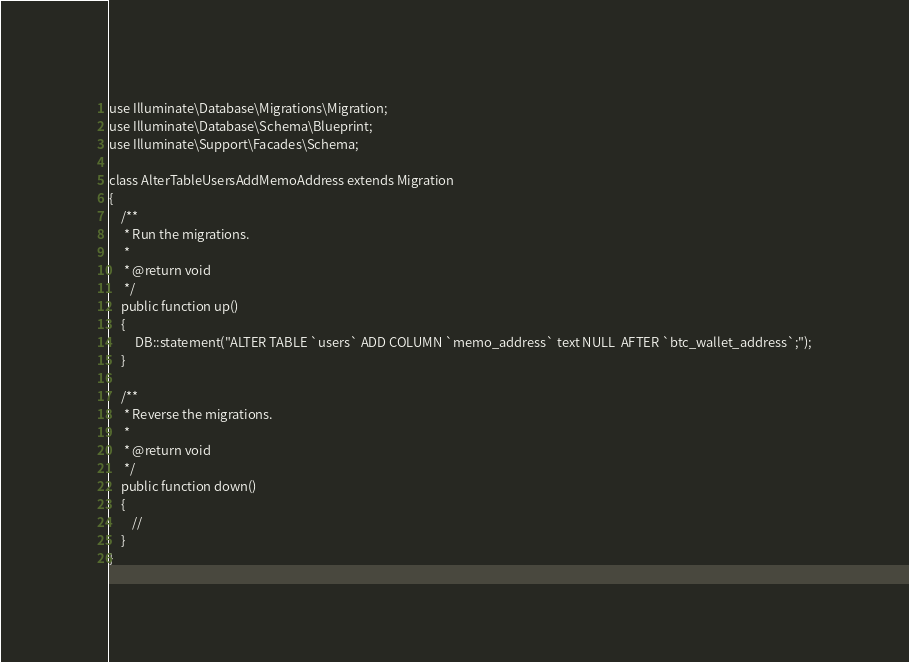Convert code to text. <code><loc_0><loc_0><loc_500><loc_500><_PHP_>use Illuminate\Database\Migrations\Migration;
use Illuminate\Database\Schema\Blueprint;
use Illuminate\Support\Facades\Schema;

class AlterTableUsersAddMemoAddress extends Migration
{
    /**
     * Run the migrations.
     *
     * @return void
     */
    public function up()
    {
         DB::statement("ALTER TABLE `users` ADD COLUMN `memo_address` text NULL  AFTER `btc_wallet_address`;");
    }

    /**
     * Reverse the migrations.
     *
     * @return void
     */
    public function down()
    {
        //
    }
}
</code> 